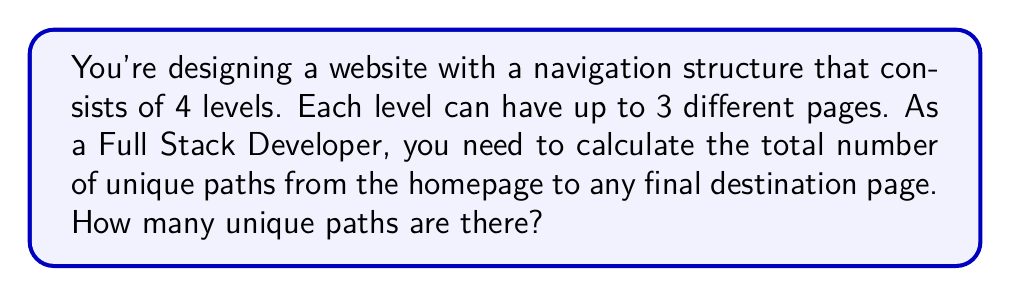Help me with this question. Let's approach this step-by-step:

1) First, we need to understand what constitutes a path:
   - A path starts from the homepage and ends at any page on the 4th level.
   - At each level, we have a choice of up to 3 pages.

2) This scenario can be modeled as a tree structure with a depth of 4 and a maximum branching factor of 3.

3) To count the number of unique paths, we can use the multiplication principle:
   - For each level, we multiply the number of choices.

4) Let's calculate:
   - Level 1 (homepage): 1 choice
   - Level 2: 3 choices
   - Level 3: 3 choices
   - Level 4: 3 choices

5) Therefore, the total number of unique paths is:

   $$ 1 \times 3 \times 3 \times 3 = 3^3 = 27 $$

6) We can also express this mathematically as:

   $$ \text{Total paths} = \prod_{i=1}^{3} 3 = 3^3 $$

   Where 3 is the number of choices at each level (except the homepage), and we're multiplying 3 times (for levels 2, 3, and 4).
Answer: 27 